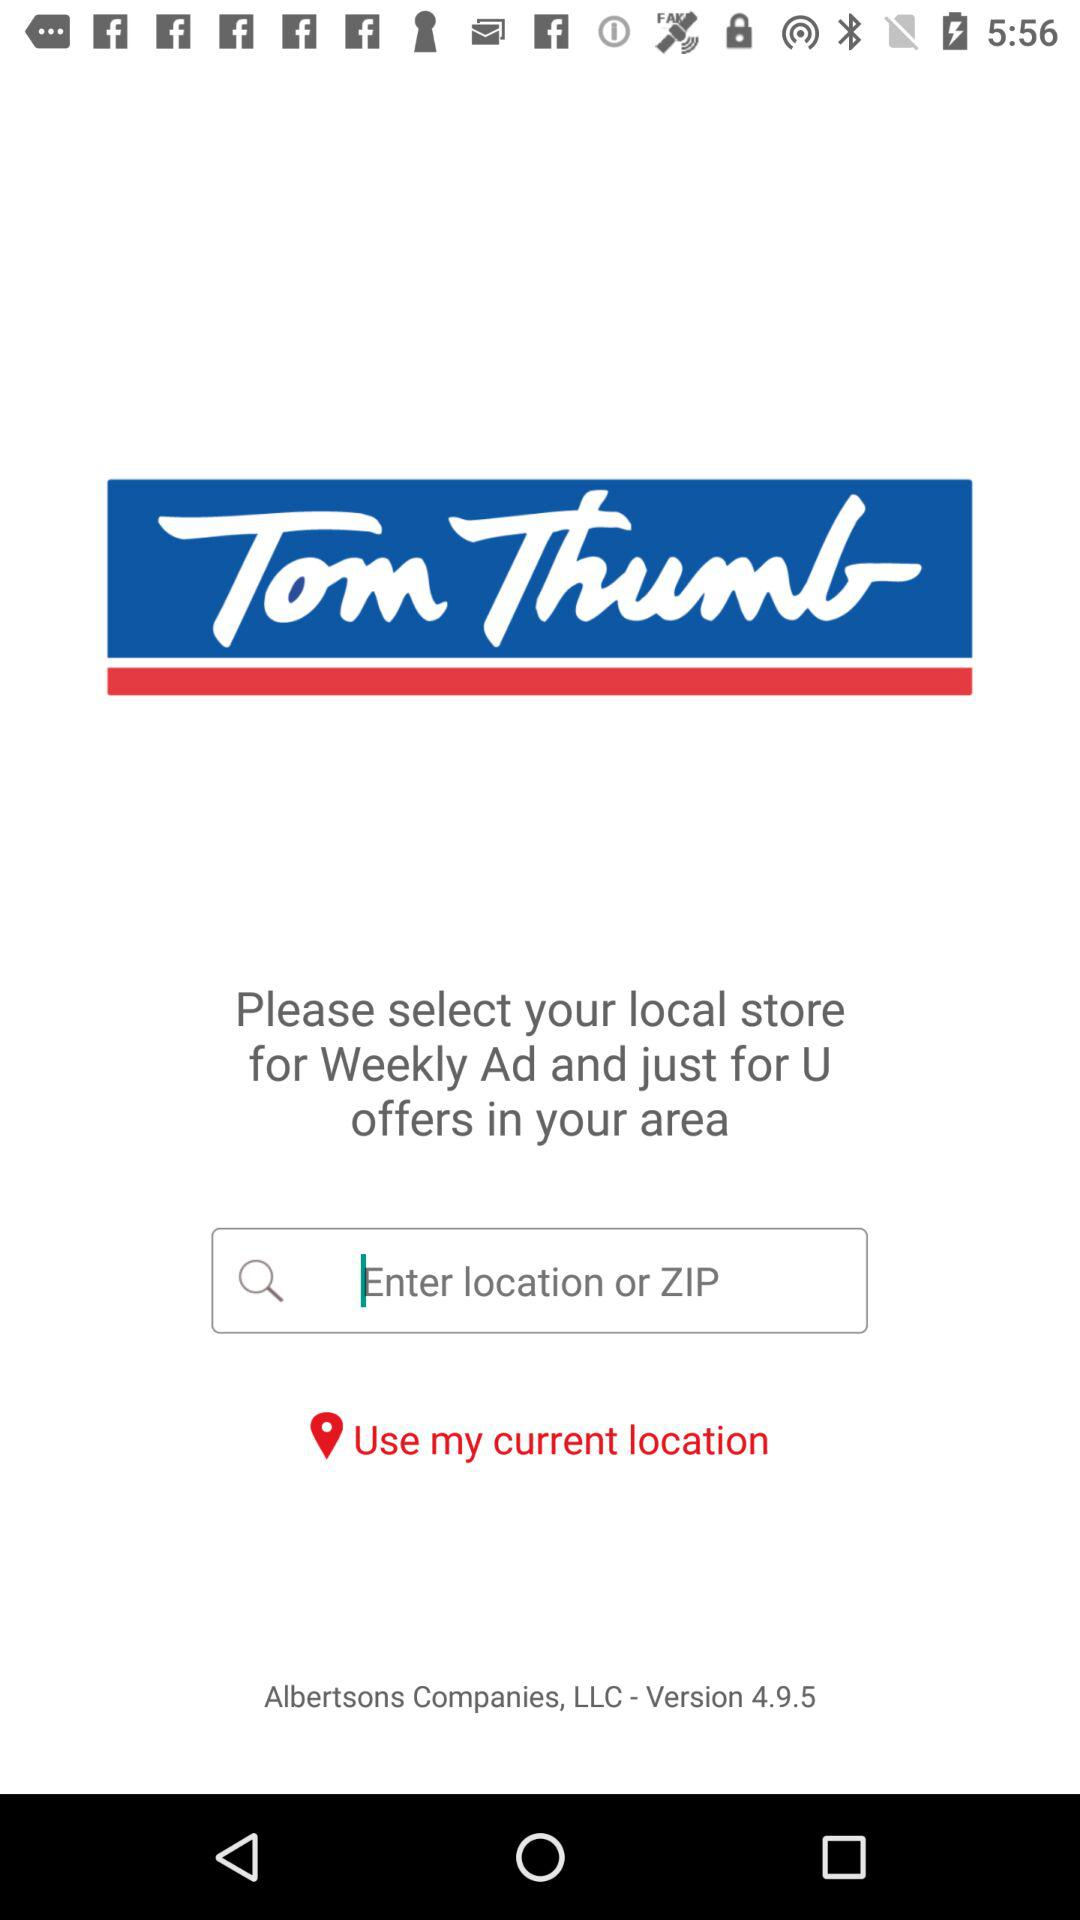What is the version of the application? The version is 4.9.5. 